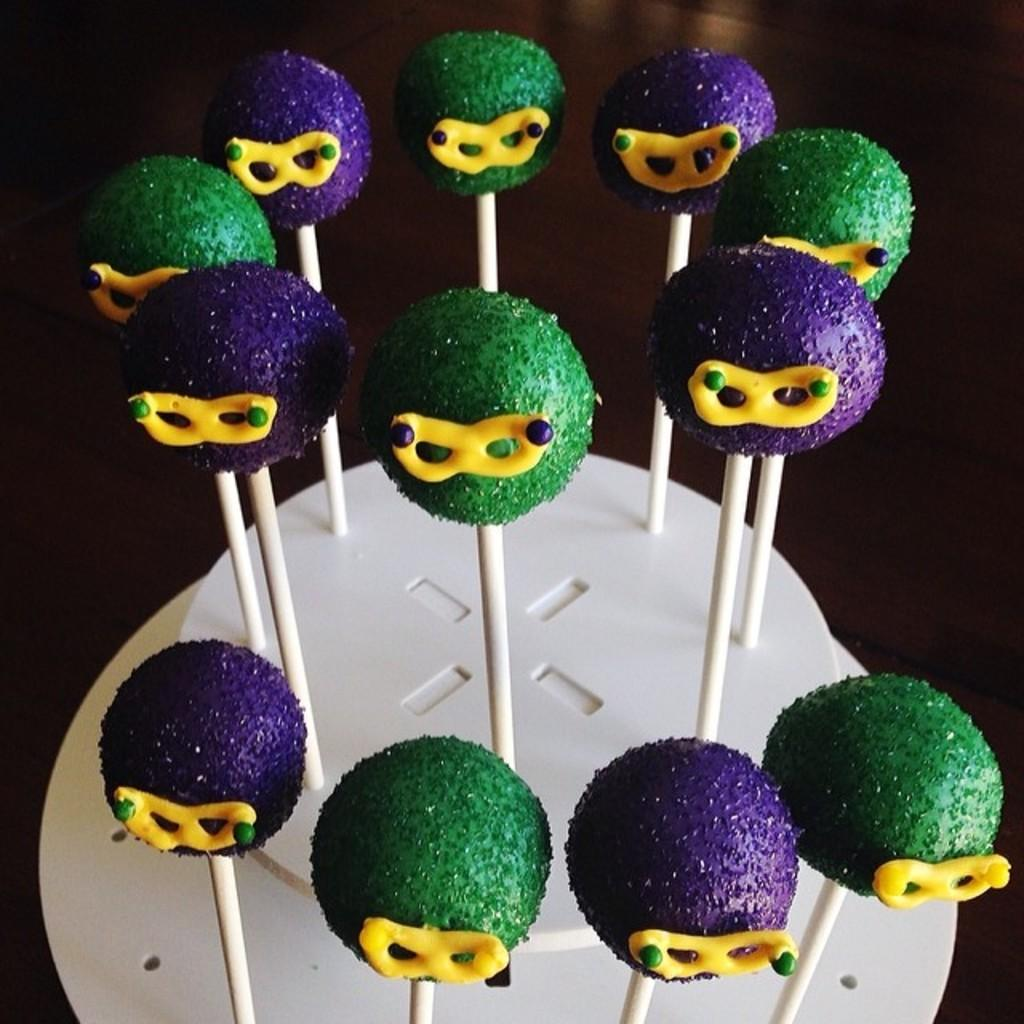What type of food items are present in the image? There are candies in the image. Can you describe the colors of the candies? Some candies are green in color, and some are violet in color. What is the color of the background in the image? The background of the image is black. How does the growth of the candies affect the image? The candies in the image are not growing, as they are inanimate objects. Is there any rain visible in the image? There is no rain present in the image; it features candies against a black background. 